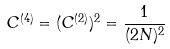Convert formula to latex. <formula><loc_0><loc_0><loc_500><loc_500>C ^ { ( 4 ) } = ( C ^ { ( 2 ) } ) ^ { 2 } = \frac { 1 } { ( 2 N ) ^ { 2 } }</formula> 